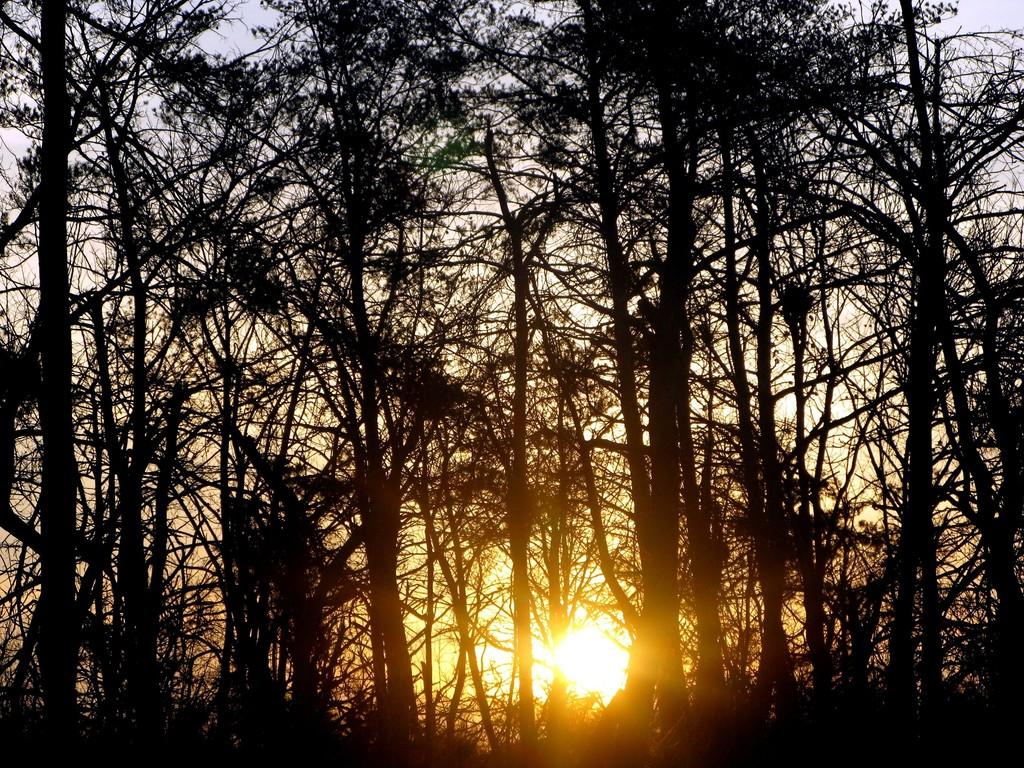What is the main feature of the image? The main feature of the image is the presence of many trees. What can be seen in the background of the image? The sun and the sky are visible in the back of the image. What type of vessel is being used to measure the interest in the image? There is no vessel or measurement of interest present in the image; it features trees and a sky with the sun visible. 